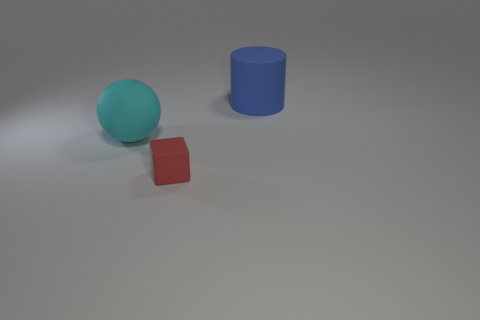There is a matte object that is in front of the cyan ball; is there a large blue cylinder that is in front of it?
Offer a terse response. No. There is a object that is both behind the tiny cube and in front of the blue rubber thing; what color is it?
Your answer should be compact. Cyan. The blue cylinder has what size?
Make the answer very short. Large. What number of other red rubber cubes are the same size as the red cube?
Make the answer very short. 0. What is the material of the large object that is to the left of the large rubber object right of the small red thing?
Your answer should be very brief. Rubber. There is a thing behind the cyan rubber object; what is it made of?
Offer a terse response. Rubber. What number of other red matte objects have the same shape as the tiny red thing?
Give a very brief answer. 0. What is the material of the object behind the large object that is in front of the rubber thing that is behind the cyan sphere?
Provide a short and direct response. Rubber. Are there any rubber objects on the left side of the rubber block?
Offer a terse response. Yes. The thing that is the same size as the sphere is what shape?
Ensure brevity in your answer.  Cylinder. 